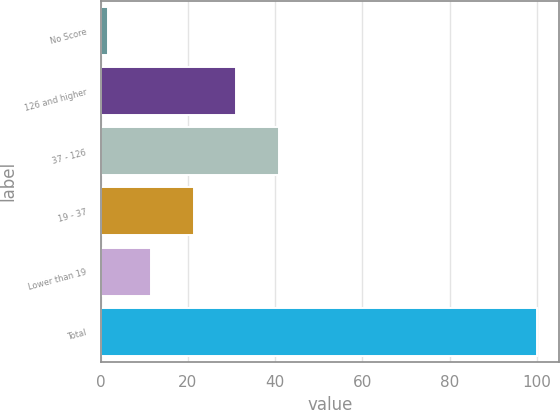Convert chart. <chart><loc_0><loc_0><loc_500><loc_500><bar_chart><fcel>No Score<fcel>126 and higher<fcel>37 - 126<fcel>19 - 37<fcel>Lower than 19<fcel>Total<nl><fcel>1.6<fcel>31.12<fcel>40.96<fcel>21.28<fcel>11.44<fcel>100<nl></chart> 